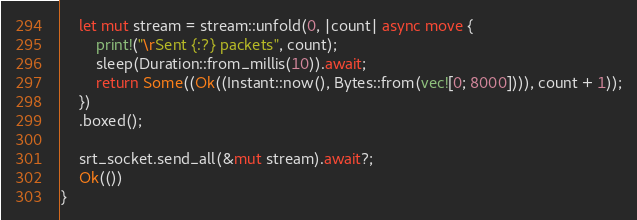<code> <loc_0><loc_0><loc_500><loc_500><_Rust_>
    let mut stream = stream::unfold(0, |count| async move {
        print!("\rSent {:?} packets", count);
        sleep(Duration::from_millis(10)).await;
        return Some((Ok((Instant::now(), Bytes::from(vec![0; 8000]))), count + 1));
    })
    .boxed();

    srt_socket.send_all(&mut stream).await?;
    Ok(())
}
</code> 